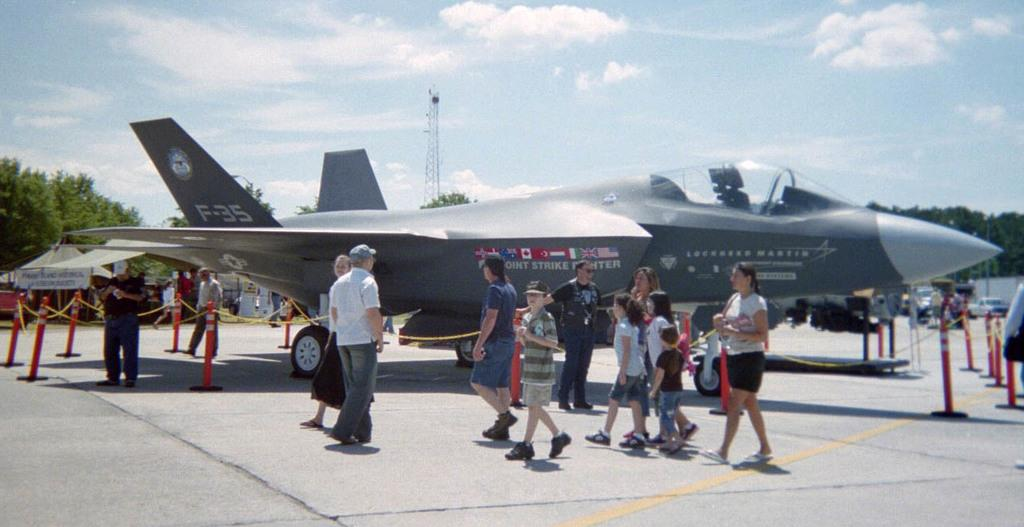What is the main subject of the image? The main subject of the image is an airplane. What other objects can be seen in the image? There are poles and a fence in the image. Are there any people in the image? Yes, there are people walking in the image. Can you tell me how many volcanoes are visible in the image? There are no volcanoes present in the image. What type of joke is being told by the people walking in the image? There is no indication of a joke being told in the image; the people are simply walking. 